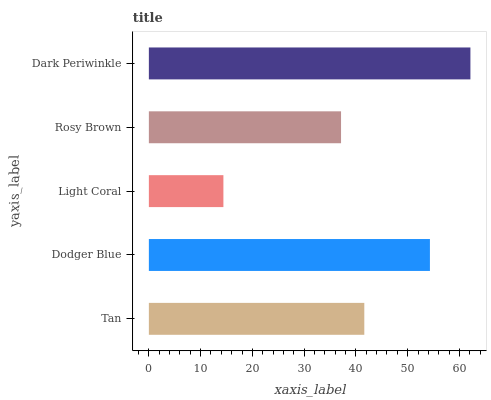Is Light Coral the minimum?
Answer yes or no. Yes. Is Dark Periwinkle the maximum?
Answer yes or no. Yes. Is Dodger Blue the minimum?
Answer yes or no. No. Is Dodger Blue the maximum?
Answer yes or no. No. Is Dodger Blue greater than Tan?
Answer yes or no. Yes. Is Tan less than Dodger Blue?
Answer yes or no. Yes. Is Tan greater than Dodger Blue?
Answer yes or no. No. Is Dodger Blue less than Tan?
Answer yes or no. No. Is Tan the high median?
Answer yes or no. Yes. Is Tan the low median?
Answer yes or no. Yes. Is Dodger Blue the high median?
Answer yes or no. No. Is Dark Periwinkle the low median?
Answer yes or no. No. 